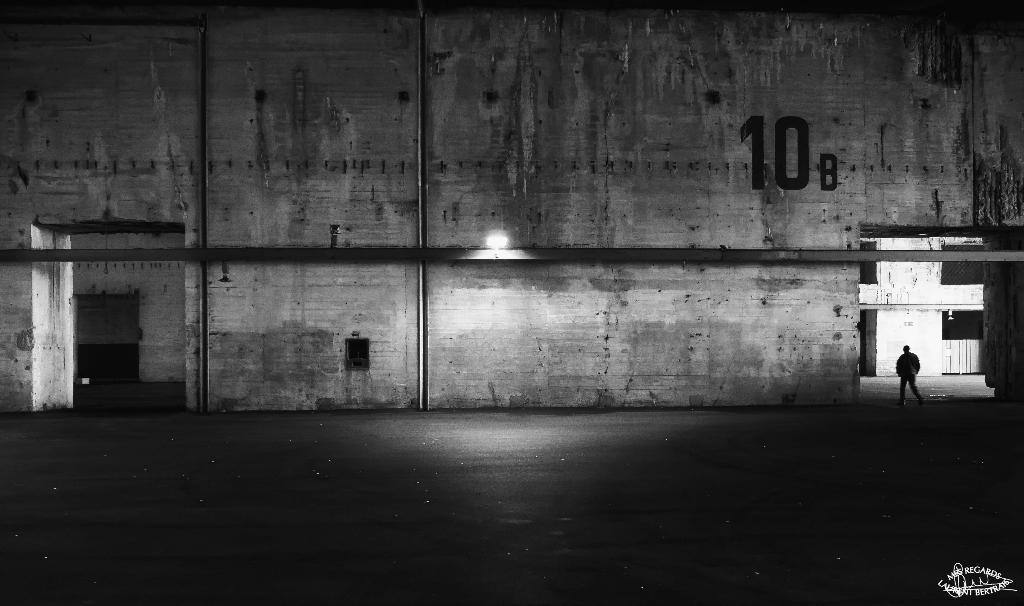What is the main subject of the image? There is a person standing in the image. Where is the person standing? The person is standing on the floor. What can be seen in the background of the image? There is a building in the background of the image. What is the source of light in the image? There is a street light in the image. How many friends is the person talking to in the image? There is no indication of friends or a conversation in the image. What type of step is the person using to climb the building in the image? There is no step or attempt to climb the building in the image. 